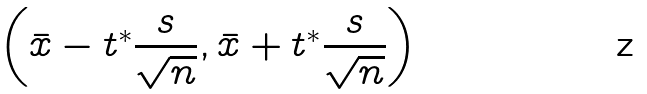<formula> <loc_0><loc_0><loc_500><loc_500>\left ( { \bar { x } } - t ^ { * } { \frac { s } { \sqrt { n } } } , { \bar { x } } + t ^ { * } { \frac { s } { \sqrt { n } } } \right )</formula> 